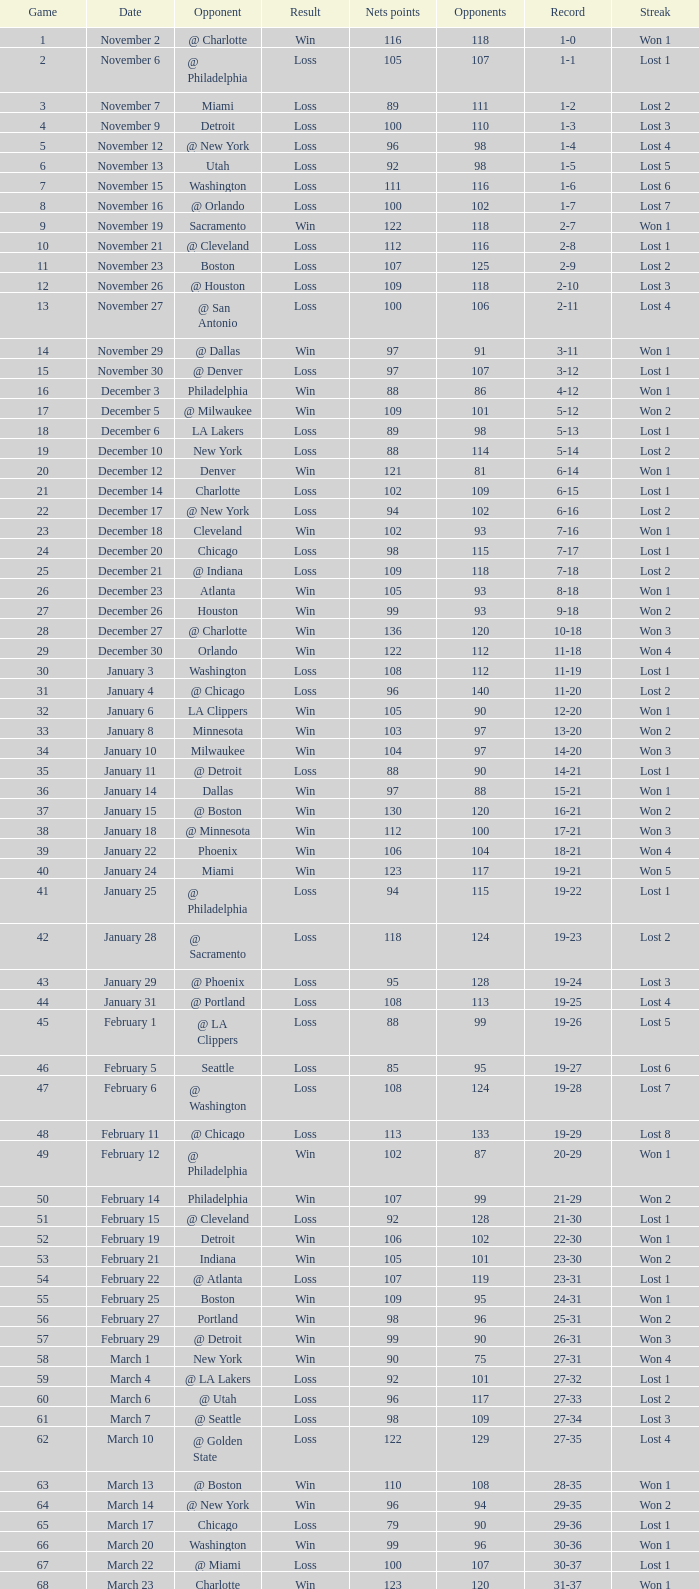Would you mind parsing the complete table? {'header': ['Game', 'Date', 'Opponent', 'Result', 'Nets points', 'Opponents', 'Record', 'Streak'], 'rows': [['1', 'November 2', '@ Charlotte', 'Win', '116', '118', '1-0', 'Won 1'], ['2', 'November 6', '@ Philadelphia', 'Loss', '105', '107', '1-1', 'Lost 1'], ['3', 'November 7', 'Miami', 'Loss', '89', '111', '1-2', 'Lost 2'], ['4', 'November 9', 'Detroit', 'Loss', '100', '110', '1-3', 'Lost 3'], ['5', 'November 12', '@ New York', 'Loss', '96', '98', '1-4', 'Lost 4'], ['6', 'November 13', 'Utah', 'Loss', '92', '98', '1-5', 'Lost 5'], ['7', 'November 15', 'Washington', 'Loss', '111', '116', '1-6', 'Lost 6'], ['8', 'November 16', '@ Orlando', 'Loss', '100', '102', '1-7', 'Lost 7'], ['9', 'November 19', 'Sacramento', 'Win', '122', '118', '2-7', 'Won 1'], ['10', 'November 21', '@ Cleveland', 'Loss', '112', '116', '2-8', 'Lost 1'], ['11', 'November 23', 'Boston', 'Loss', '107', '125', '2-9', 'Lost 2'], ['12', 'November 26', '@ Houston', 'Loss', '109', '118', '2-10', 'Lost 3'], ['13', 'November 27', '@ San Antonio', 'Loss', '100', '106', '2-11', 'Lost 4'], ['14', 'November 29', '@ Dallas', 'Win', '97', '91', '3-11', 'Won 1'], ['15', 'November 30', '@ Denver', 'Loss', '97', '107', '3-12', 'Lost 1'], ['16', 'December 3', 'Philadelphia', 'Win', '88', '86', '4-12', 'Won 1'], ['17', 'December 5', '@ Milwaukee', 'Win', '109', '101', '5-12', 'Won 2'], ['18', 'December 6', 'LA Lakers', 'Loss', '89', '98', '5-13', 'Lost 1'], ['19', 'December 10', 'New York', 'Loss', '88', '114', '5-14', 'Lost 2'], ['20', 'December 12', 'Denver', 'Win', '121', '81', '6-14', 'Won 1'], ['21', 'December 14', 'Charlotte', 'Loss', '102', '109', '6-15', 'Lost 1'], ['22', 'December 17', '@ New York', 'Loss', '94', '102', '6-16', 'Lost 2'], ['23', 'December 18', 'Cleveland', 'Win', '102', '93', '7-16', 'Won 1'], ['24', 'December 20', 'Chicago', 'Loss', '98', '115', '7-17', 'Lost 1'], ['25', 'December 21', '@ Indiana', 'Loss', '109', '118', '7-18', 'Lost 2'], ['26', 'December 23', 'Atlanta', 'Win', '105', '93', '8-18', 'Won 1'], ['27', 'December 26', 'Houston', 'Win', '99', '93', '9-18', 'Won 2'], ['28', 'December 27', '@ Charlotte', 'Win', '136', '120', '10-18', 'Won 3'], ['29', 'December 30', 'Orlando', 'Win', '122', '112', '11-18', 'Won 4'], ['30', 'January 3', 'Washington', 'Loss', '108', '112', '11-19', 'Lost 1'], ['31', 'January 4', '@ Chicago', 'Loss', '96', '140', '11-20', 'Lost 2'], ['32', 'January 6', 'LA Clippers', 'Win', '105', '90', '12-20', 'Won 1'], ['33', 'January 8', 'Minnesota', 'Win', '103', '97', '13-20', 'Won 2'], ['34', 'January 10', 'Milwaukee', 'Win', '104', '97', '14-20', 'Won 3'], ['35', 'January 11', '@ Detroit', 'Loss', '88', '90', '14-21', 'Lost 1'], ['36', 'January 14', 'Dallas', 'Win', '97', '88', '15-21', 'Won 1'], ['37', 'January 15', '@ Boston', 'Win', '130', '120', '16-21', 'Won 2'], ['38', 'January 18', '@ Minnesota', 'Win', '112', '100', '17-21', 'Won 3'], ['39', 'January 22', 'Phoenix', 'Win', '106', '104', '18-21', 'Won 4'], ['40', 'January 24', 'Miami', 'Win', '123', '117', '19-21', 'Won 5'], ['41', 'January 25', '@ Philadelphia', 'Loss', '94', '115', '19-22', 'Lost 1'], ['42', 'January 28', '@ Sacramento', 'Loss', '118', '124', '19-23', 'Lost 2'], ['43', 'January 29', '@ Phoenix', 'Loss', '95', '128', '19-24', 'Lost 3'], ['44', 'January 31', '@ Portland', 'Loss', '108', '113', '19-25', 'Lost 4'], ['45', 'February 1', '@ LA Clippers', 'Loss', '88', '99', '19-26', 'Lost 5'], ['46', 'February 5', 'Seattle', 'Loss', '85', '95', '19-27', 'Lost 6'], ['47', 'February 6', '@ Washington', 'Loss', '108', '124', '19-28', 'Lost 7'], ['48', 'February 11', '@ Chicago', 'Loss', '113', '133', '19-29', 'Lost 8'], ['49', 'February 12', '@ Philadelphia', 'Win', '102', '87', '20-29', 'Won 1'], ['50', 'February 14', 'Philadelphia', 'Win', '107', '99', '21-29', 'Won 2'], ['51', 'February 15', '@ Cleveland', 'Loss', '92', '128', '21-30', 'Lost 1'], ['52', 'February 19', 'Detroit', 'Win', '106', '102', '22-30', 'Won 1'], ['53', 'February 21', 'Indiana', 'Win', '105', '101', '23-30', 'Won 2'], ['54', 'February 22', '@ Atlanta', 'Loss', '107', '119', '23-31', 'Lost 1'], ['55', 'February 25', 'Boston', 'Win', '109', '95', '24-31', 'Won 1'], ['56', 'February 27', 'Portland', 'Win', '98', '96', '25-31', 'Won 2'], ['57', 'February 29', '@ Detroit', 'Win', '99', '90', '26-31', 'Won 3'], ['58', 'March 1', 'New York', 'Win', '90', '75', '27-31', 'Won 4'], ['59', 'March 4', '@ LA Lakers', 'Loss', '92', '101', '27-32', 'Lost 1'], ['60', 'March 6', '@ Utah', 'Loss', '96', '117', '27-33', 'Lost 2'], ['61', 'March 7', '@ Seattle', 'Loss', '98', '109', '27-34', 'Lost 3'], ['62', 'March 10', '@ Golden State', 'Loss', '122', '129', '27-35', 'Lost 4'], ['63', 'March 13', '@ Boston', 'Win', '110', '108', '28-35', 'Won 1'], ['64', 'March 14', '@ New York', 'Win', '96', '94', '29-35', 'Won 2'], ['65', 'March 17', 'Chicago', 'Loss', '79', '90', '29-36', 'Lost 1'], ['66', 'March 20', 'Washington', 'Win', '99', '96', '30-36', 'Won 1'], ['67', 'March 22', '@ Miami', 'Loss', '100', '107', '30-37', 'Lost 1'], ['68', 'March 23', 'Charlotte', 'Win', '123', '120', '31-37', 'Won 1'], ['69', 'March 25', 'Boston', 'Loss', '110', '118', '31-38', 'Lost 1'], ['70', 'March 28', 'Golden State', 'Loss', '148', '153', '31-39', 'Lost 2'], ['71', 'March 30', 'San Antonio', 'Win', '117', '109', '32-39', 'Won 1'], ['72', 'April 1', '@ Milwaukee', 'Win', '121', '117', '33-39', 'Won 2'], ['73', 'April 3', 'Milwaukee', 'Win', '122', '103', '34-39', 'Won 3'], ['74', 'April 5', '@ Indiana', 'Win', '128', '120', '35-39', 'Won 4'], ['75', 'April 7', 'Atlanta', 'Loss', '97', '104', '35-40', 'Lost 1'], ['76', 'April 8', '@ Washington', 'Win', '109', '103', '36-40', 'Won 1'], ['77', 'April 10', 'Cleveland', 'Win', '110', '86', '37-40', 'Won 2'], ['78', 'April 11', '@ Atlanta', 'Loss', '98', '118', '37-41', 'Lost 1'], ['79', 'April 13', '@ Orlando', 'Win', '110', '104', '38-41', 'Won 1'], ['80', 'April 14', '@ Miami', 'Win', '105', '100', '39-41', 'Won 2'], ['81', 'April 16', 'Indiana', 'Loss', '113', '119', '39-42', 'Lost 1'], ['82', 'April 18', 'Orlando', 'Win', '127', '111', '40-42', 'Won 1'], ['1', 'April 23', '@ Cleveland', 'Loss', '113', '120', '0-1', 'Lost 1'], ['2', 'April 25', '@ Cleveland', 'Loss', '96', '118', '0-2', 'Lost 2'], ['3', 'April 28', 'Cleveland', 'Win', '109', '104', '1-2', 'Won 1'], ['4', 'April 30', 'Cleveland', 'Loss', '89', '98', '1-3', 'Lost 1']]} How many opponents were there in a game higher than 20 on January 28? 124.0. 